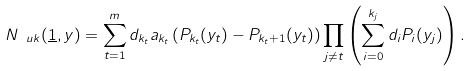Convert formula to latex. <formula><loc_0><loc_0><loc_500><loc_500>N _ { \ u k } ( \underline { 1 } , y ) = \sum _ { t = 1 } ^ { m } d _ { k _ { t } } a _ { k _ { t } } \left ( P _ { k _ { t } } ( y _ { t } ) - P _ { k _ { t } + 1 } ( y _ { t } ) \right ) \prod _ { j \neq t } \left ( \sum _ { i = 0 } ^ { k _ { j } } d _ { i } P _ { i } ( y _ { j } ) \right ) .</formula> 